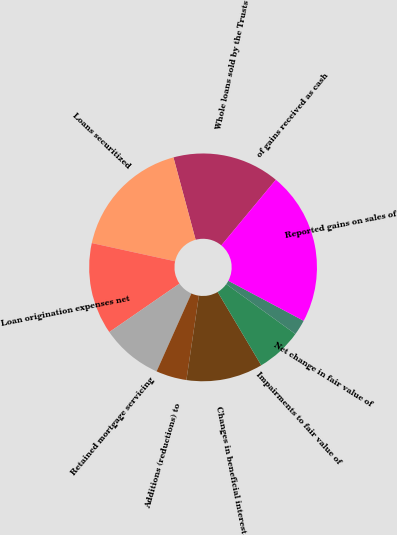Convert chart to OTSL. <chart><loc_0><loc_0><loc_500><loc_500><pie_chart><fcel>Whole loans sold by the Trusts<fcel>Loans securitized<fcel>Loan origination expenses net<fcel>Retained mortgage servicing<fcel>Additions (reductions) to<fcel>Changes in beneficial interest<fcel>Impairments to fair value of<fcel>Net change in fair value of<fcel>Reported gains on sales of<fcel>of gains received as cash<nl><fcel>15.22%<fcel>17.39%<fcel>13.04%<fcel>8.7%<fcel>4.35%<fcel>10.87%<fcel>6.52%<fcel>2.18%<fcel>21.74%<fcel>0.0%<nl></chart> 